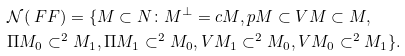<formula> <loc_0><loc_0><loc_500><loc_500>& \mathcal { N } ( \ F F ) = \{ M \subset N \colon M ^ { \perp } = c M , p M \subset V M \subset M , \\ & \Pi M _ { 0 } \subset ^ { 2 } M _ { 1 } , \Pi M _ { 1 } \subset ^ { 2 } M _ { 0 } , V M _ { 1 } \subset ^ { 2 } M _ { 0 } , V M _ { 0 } \subset ^ { 2 } M _ { 1 } \} . \\</formula> 